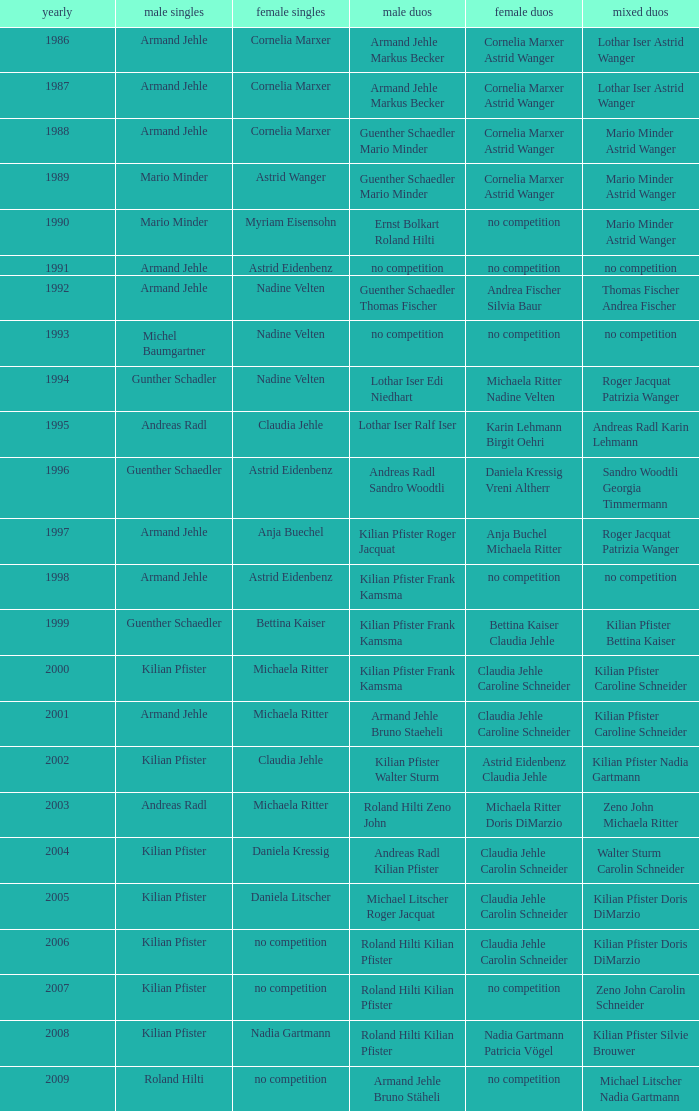What is the most current year where the women's doubles champions are astrid eidenbenz claudia jehle 2002.0. Parse the full table. {'header': ['yearly', 'male singles', 'female singles', 'male duos', 'female duos', 'mixed duos'], 'rows': [['1986', 'Armand Jehle', 'Cornelia Marxer', 'Armand Jehle Markus Becker', 'Cornelia Marxer Astrid Wanger', 'Lothar Iser Astrid Wanger'], ['1987', 'Armand Jehle', 'Cornelia Marxer', 'Armand Jehle Markus Becker', 'Cornelia Marxer Astrid Wanger', 'Lothar Iser Astrid Wanger'], ['1988', 'Armand Jehle', 'Cornelia Marxer', 'Guenther Schaedler Mario Minder', 'Cornelia Marxer Astrid Wanger', 'Mario Minder Astrid Wanger'], ['1989', 'Mario Minder', 'Astrid Wanger', 'Guenther Schaedler Mario Minder', 'Cornelia Marxer Astrid Wanger', 'Mario Minder Astrid Wanger'], ['1990', 'Mario Minder', 'Myriam Eisensohn', 'Ernst Bolkart Roland Hilti', 'no competition', 'Mario Minder Astrid Wanger'], ['1991', 'Armand Jehle', 'Astrid Eidenbenz', 'no competition', 'no competition', 'no competition'], ['1992', 'Armand Jehle', 'Nadine Velten', 'Guenther Schaedler Thomas Fischer', 'Andrea Fischer Silvia Baur', 'Thomas Fischer Andrea Fischer'], ['1993', 'Michel Baumgartner', 'Nadine Velten', 'no competition', 'no competition', 'no competition'], ['1994', 'Gunther Schadler', 'Nadine Velten', 'Lothar Iser Edi Niedhart', 'Michaela Ritter Nadine Velten', 'Roger Jacquat Patrizia Wanger'], ['1995', 'Andreas Radl', 'Claudia Jehle', 'Lothar Iser Ralf Iser', 'Karin Lehmann Birgit Oehri', 'Andreas Radl Karin Lehmann'], ['1996', 'Guenther Schaedler', 'Astrid Eidenbenz', 'Andreas Radl Sandro Woodtli', 'Daniela Kressig Vreni Altherr', 'Sandro Woodtli Georgia Timmermann'], ['1997', 'Armand Jehle', 'Anja Buechel', 'Kilian Pfister Roger Jacquat', 'Anja Buchel Michaela Ritter', 'Roger Jacquat Patrizia Wanger'], ['1998', 'Armand Jehle', 'Astrid Eidenbenz', 'Kilian Pfister Frank Kamsma', 'no competition', 'no competition'], ['1999', 'Guenther Schaedler', 'Bettina Kaiser', 'Kilian Pfister Frank Kamsma', 'Bettina Kaiser Claudia Jehle', 'Kilian Pfister Bettina Kaiser'], ['2000', 'Kilian Pfister', 'Michaela Ritter', 'Kilian Pfister Frank Kamsma', 'Claudia Jehle Caroline Schneider', 'Kilian Pfister Caroline Schneider'], ['2001', 'Armand Jehle', 'Michaela Ritter', 'Armand Jehle Bruno Staeheli', 'Claudia Jehle Caroline Schneider', 'Kilian Pfister Caroline Schneider'], ['2002', 'Kilian Pfister', 'Claudia Jehle', 'Kilian Pfister Walter Sturm', 'Astrid Eidenbenz Claudia Jehle', 'Kilian Pfister Nadia Gartmann'], ['2003', 'Andreas Radl', 'Michaela Ritter', 'Roland Hilti Zeno John', 'Michaela Ritter Doris DiMarzio', 'Zeno John Michaela Ritter'], ['2004', 'Kilian Pfister', 'Daniela Kressig', 'Andreas Radl Kilian Pfister', 'Claudia Jehle Carolin Schneider', 'Walter Sturm Carolin Schneider'], ['2005', 'Kilian Pfister', 'Daniela Litscher', 'Michael Litscher Roger Jacquat', 'Claudia Jehle Carolin Schneider', 'Kilian Pfister Doris DiMarzio'], ['2006', 'Kilian Pfister', 'no competition', 'Roland Hilti Kilian Pfister', 'Claudia Jehle Carolin Schneider', 'Kilian Pfister Doris DiMarzio'], ['2007', 'Kilian Pfister', 'no competition', 'Roland Hilti Kilian Pfister', 'no competition', 'Zeno John Carolin Schneider'], ['2008', 'Kilian Pfister', 'Nadia Gartmann', 'Roland Hilti Kilian Pfister', 'Nadia Gartmann Patricia Vögel', 'Kilian Pfister Silvie Brouwer'], ['2009', 'Roland Hilti', 'no competition', 'Armand Jehle Bruno Stäheli', 'no competition', 'Michael Litscher Nadia Gartmann']]} 